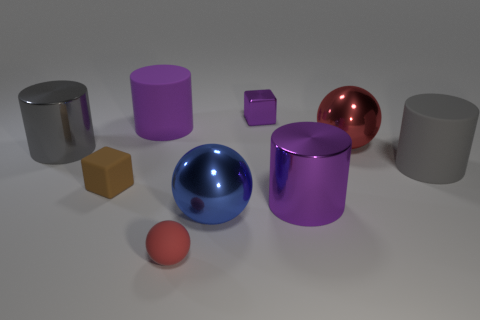What is the material of the big gray thing right of the big rubber thing behind the thing on the left side of the brown rubber object?
Your answer should be compact. Rubber. Is there a metal thing that has the same size as the matte cube?
Your answer should be compact. Yes. There is a large object that is left of the small brown rubber block in front of the tiny purple cube; what color is it?
Offer a terse response. Gray. What number of large matte cylinders are there?
Make the answer very short. 2. Is the number of gray objects behind the tiny purple block less than the number of big things that are in front of the large red shiny thing?
Your answer should be compact. Yes. The shiny cube is what color?
Your answer should be compact. Purple. What number of large metallic objects have the same color as the small metal cube?
Provide a succinct answer. 1. There is a big purple shiny object; are there any big cylinders on the left side of it?
Ensure brevity in your answer.  Yes. Are there the same number of tiny red objects that are behind the matte sphere and small purple metallic cubes that are left of the blue sphere?
Provide a succinct answer. Yes. Do the purple cylinder on the left side of the large purple metallic object and the gray thing to the right of the red rubber sphere have the same size?
Your answer should be compact. Yes. 